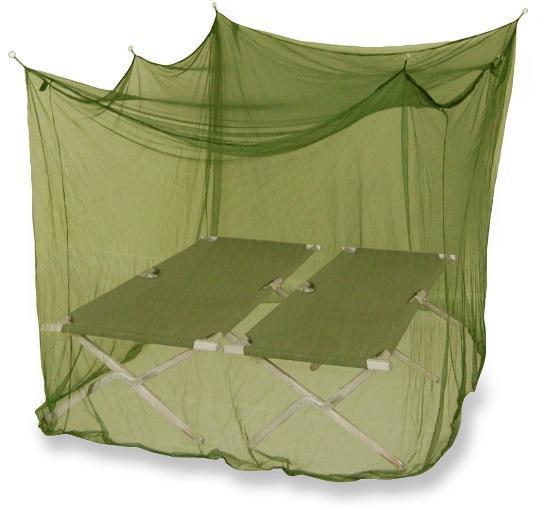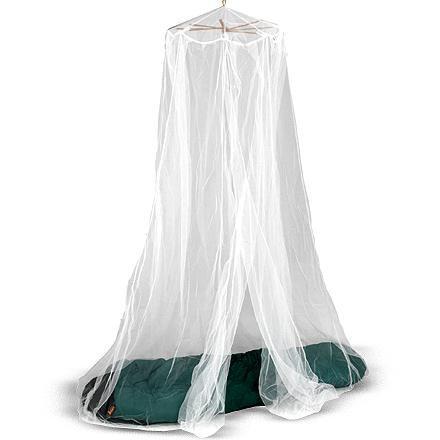The first image is the image on the left, the second image is the image on the right. Given the left and right images, does the statement "Green netting hangs over two cots in one of the images." hold true? Answer yes or no. Yes. The first image is the image on the left, the second image is the image on the right. Evaluate the accuracy of this statement regarding the images: "There are two canopies and at least one is green a square.". Is it true? Answer yes or no. Yes. 